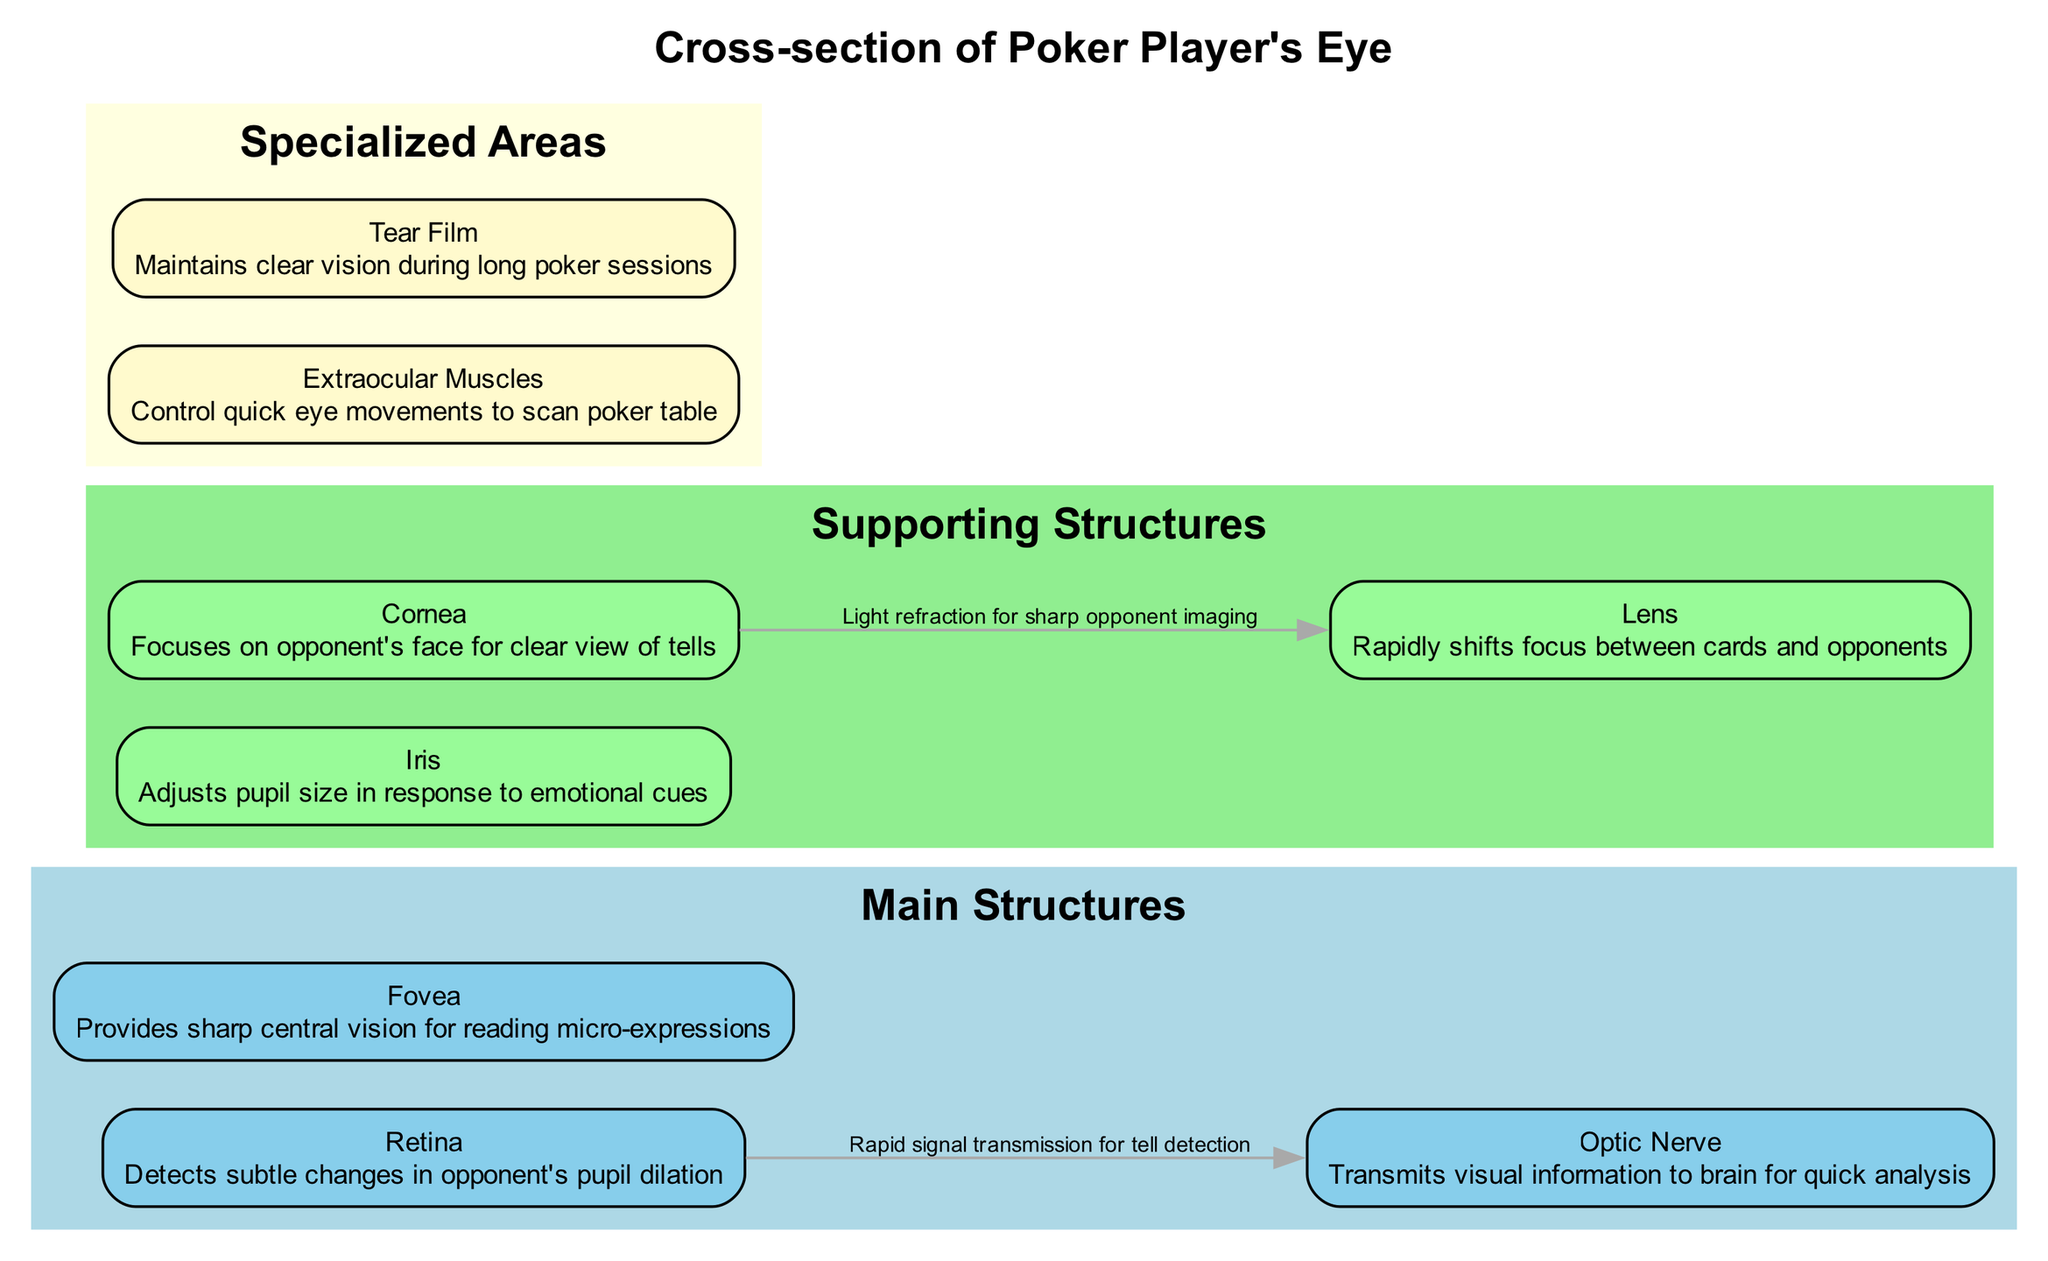What is the title of the diagram? The title of the diagram is stated at the top of the visual representation, which is explicitly mentioned in the data provided.
Answer: Cross-section of Poker Player's Eye How many main structures are there? The data specifies the "main_structures" list, which contains three items. By counting these items, we find that there are three main structures depicted in the diagram.
Answer: 3 What does the Iris do? Referring to the description associated with the Iris in the supporting structures, it states that the Iris "adjusts pupil size in response to emotional cues." This provides a direct answer from the diagram's content.
Answer: Adjusts pupil size What is the connection between Retina and Optic Nerve? The diagram includes a connection that describes the relationship between the Retina and the Optic Nerve as "Rapid signal transmission for tell detection." This is explicitly stated in the connections section of the data.
Answer: Rapid signal transmission for tell detection Which structure is responsible for sharp central vision? The description for the Fovea, found within the main structures, indicates it "provides sharp central vision for reading micro-expressions," thus answering the question.
Answer: Fovea How does the Cornea contribute to seeing an opponent? The connection description between the Cornea and the Lens states that it involves "Light refraction for sharp opponent imaging." This explains how the Cornea aids in clarity while viewing opponents.
Answer: Light refraction What is the function of Extraocular Muscles? The description provided for Extraocular Muscles states they "control quick eye movements to scan poker table." This indicates their primary function visualized in this context.
Answer: Control quick eye movements What maintains clear vision during long poker sessions? The Tear Film is identified in the specialized areas with the description "maintains clear vision during long poker sessions," which directly answers the question about maintaining clarity.
Answer: Tear Film How many supporting structures are listed? The data outlines the supporting structures and counts them, finding there are three entries listed under the supporting structures.
Answer: 3 